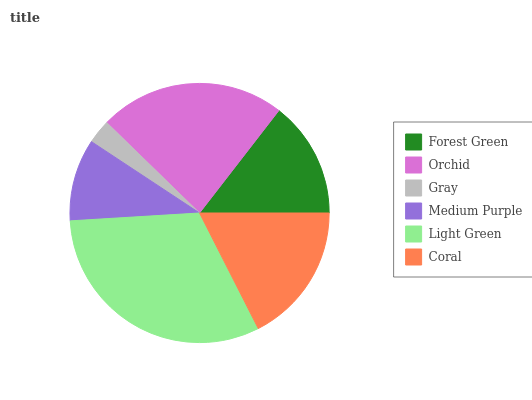Is Gray the minimum?
Answer yes or no. Yes. Is Light Green the maximum?
Answer yes or no. Yes. Is Orchid the minimum?
Answer yes or no. No. Is Orchid the maximum?
Answer yes or no. No. Is Orchid greater than Forest Green?
Answer yes or no. Yes. Is Forest Green less than Orchid?
Answer yes or no. Yes. Is Forest Green greater than Orchid?
Answer yes or no. No. Is Orchid less than Forest Green?
Answer yes or no. No. Is Coral the high median?
Answer yes or no. Yes. Is Forest Green the low median?
Answer yes or no. Yes. Is Light Green the high median?
Answer yes or no. No. Is Orchid the low median?
Answer yes or no. No. 